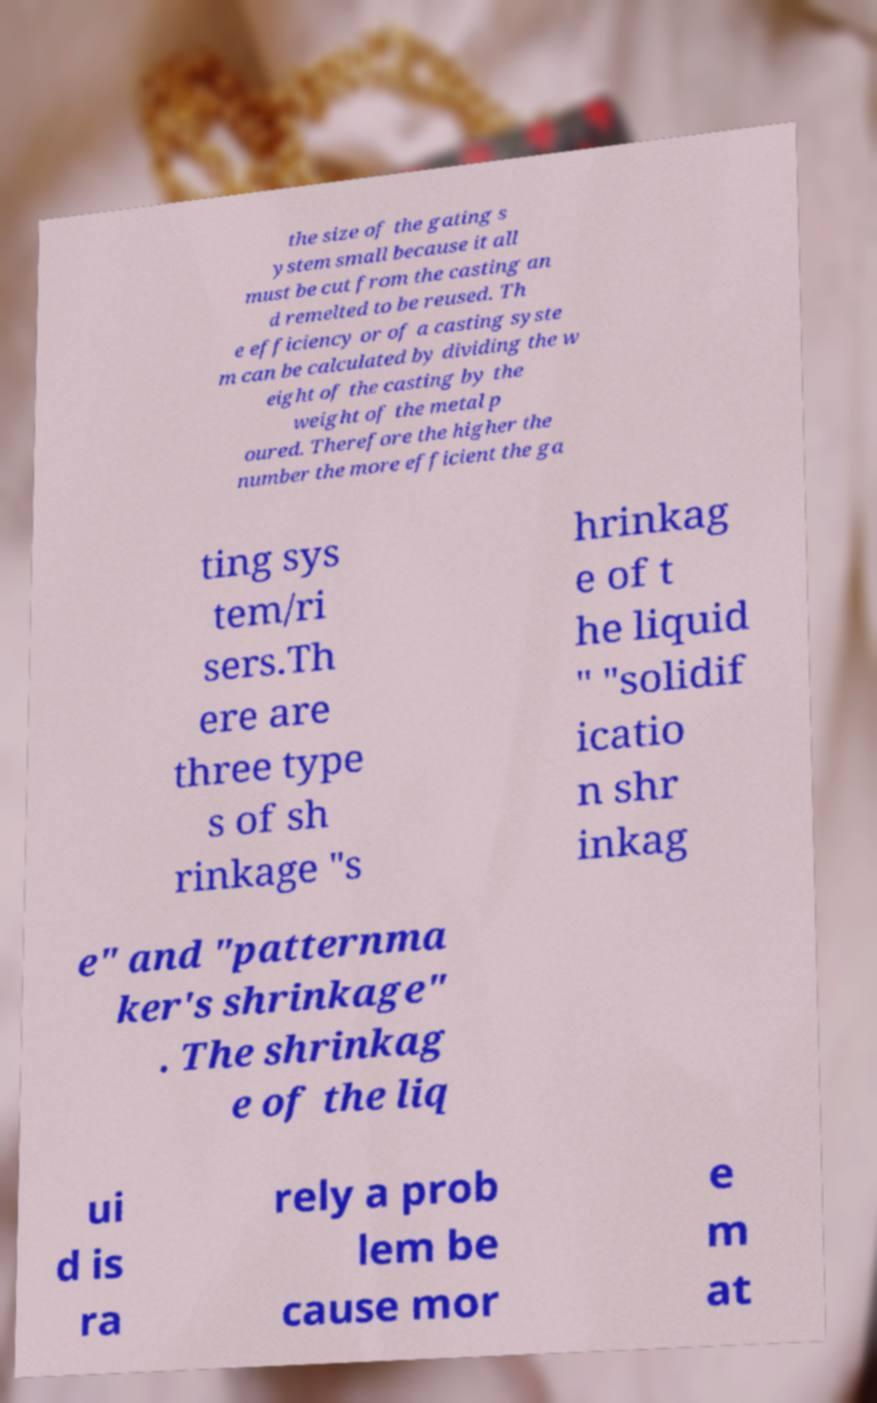What messages or text are displayed in this image? I need them in a readable, typed format. the size of the gating s ystem small because it all must be cut from the casting an d remelted to be reused. Th e efficiency or of a casting syste m can be calculated by dividing the w eight of the casting by the weight of the metal p oured. Therefore the higher the number the more efficient the ga ting sys tem/ri sers.Th ere are three type s of sh rinkage "s hrinkag e of t he liquid " "solidif icatio n shr inkag e" and "patternma ker's shrinkage" . The shrinkag e of the liq ui d is ra rely a prob lem be cause mor e m at 